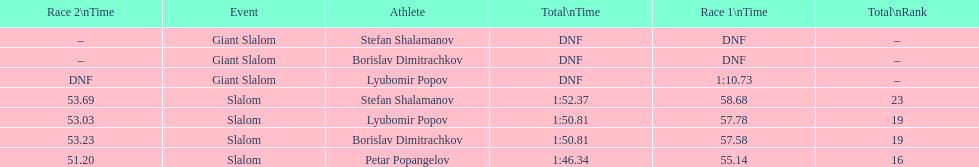Who was last in the slalom overall? Stefan Shalamanov. 